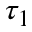Convert formula to latex. <formula><loc_0><loc_0><loc_500><loc_500>\tau _ { 1 }</formula> 